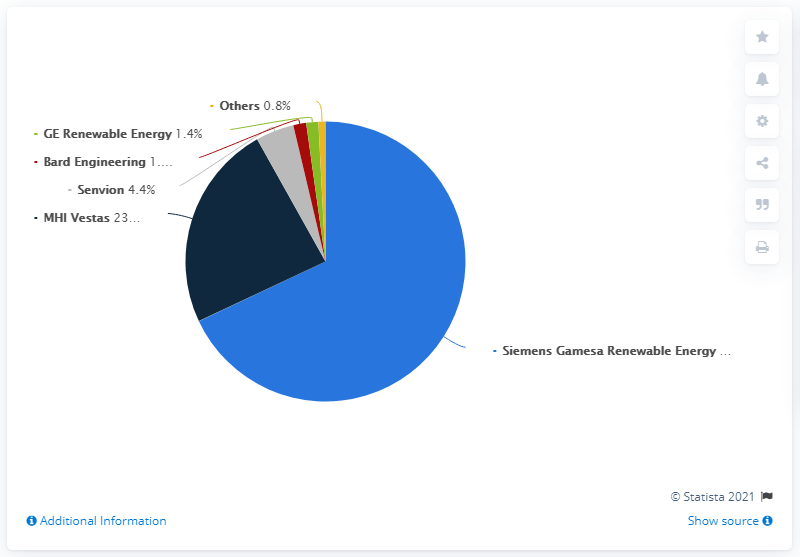Give some essential details in this illustration. Siemens Gamesa Renewable Energy is the leading offshore wind turbine manufacturer in Europe. The highest share of offshore wind turbine manufacturers in Europe in 2020 was held by Senvion, followed by Bald Engineering. The share of offshore wind turbine manufacturers in Europe in 2020 was 1%. 